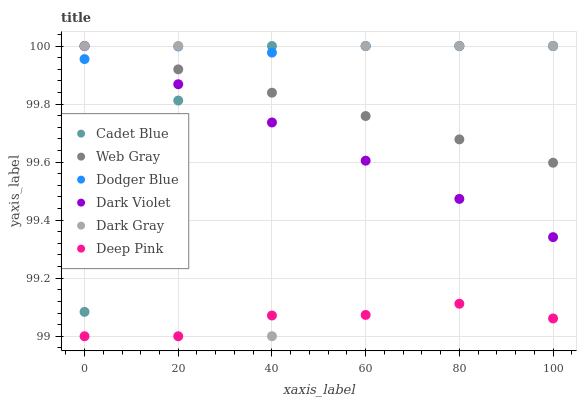Does Deep Pink have the minimum area under the curve?
Answer yes or no. Yes. Does Dodger Blue have the maximum area under the curve?
Answer yes or no. Yes. Does Dark Violet have the minimum area under the curve?
Answer yes or no. No. Does Dark Violet have the maximum area under the curve?
Answer yes or no. No. Is Dark Violet the smoothest?
Answer yes or no. Yes. Is Dark Gray the roughest?
Answer yes or no. Yes. Is Deep Pink the smoothest?
Answer yes or no. No. Is Deep Pink the roughest?
Answer yes or no. No. Does Deep Pink have the lowest value?
Answer yes or no. Yes. Does Dark Violet have the lowest value?
Answer yes or no. No. Does Dodger Blue have the highest value?
Answer yes or no. Yes. Does Deep Pink have the highest value?
Answer yes or no. No. Is Deep Pink less than Dodger Blue?
Answer yes or no. Yes. Is Dark Violet greater than Deep Pink?
Answer yes or no. Yes. Does Dark Violet intersect Dark Gray?
Answer yes or no. Yes. Is Dark Violet less than Dark Gray?
Answer yes or no. No. Is Dark Violet greater than Dark Gray?
Answer yes or no. No. Does Deep Pink intersect Dodger Blue?
Answer yes or no. No. 